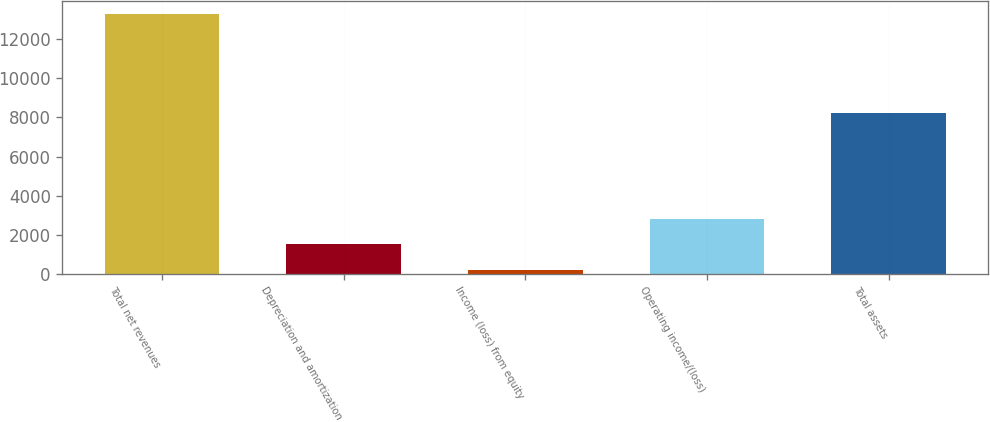Convert chart to OTSL. <chart><loc_0><loc_0><loc_500><loc_500><bar_chart><fcel>Total net revenues<fcel>Depreciation and amortization<fcel>Income (loss) from equity<fcel>Operating income/(loss)<fcel>Total assets<nl><fcel>13299.5<fcel>1519.58<fcel>210.7<fcel>2828.46<fcel>8219.2<nl></chart> 